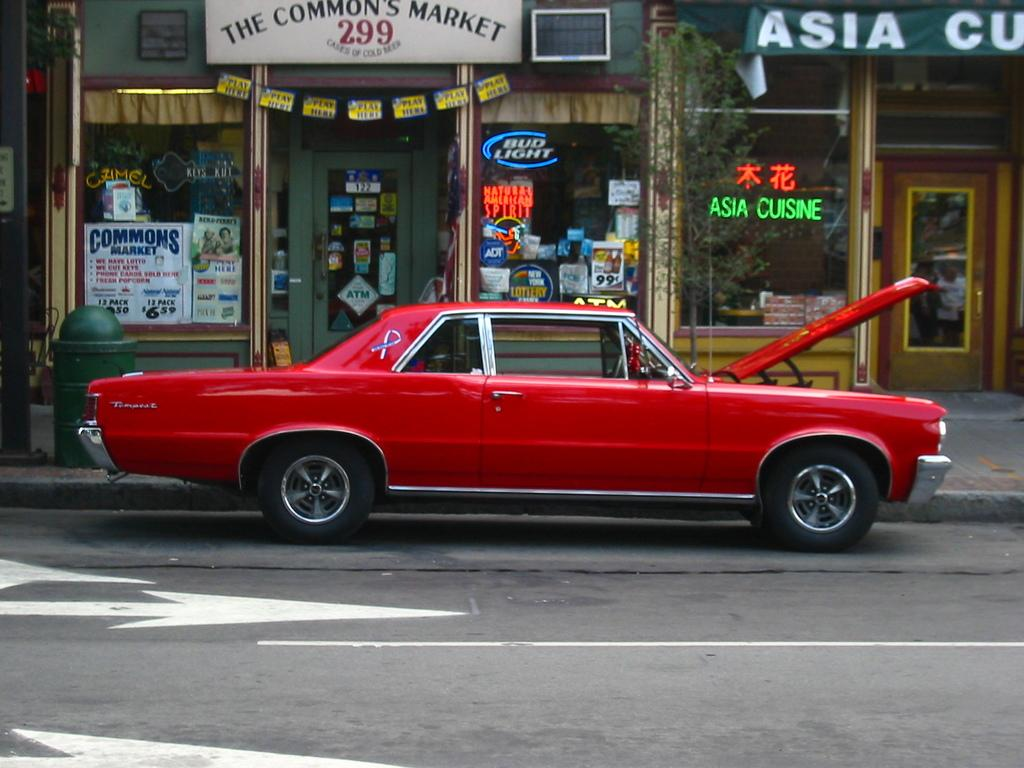<image>
Give a short and clear explanation of the subsequent image. a sign that says Asia Cuisine that is on a building in front of a red car 